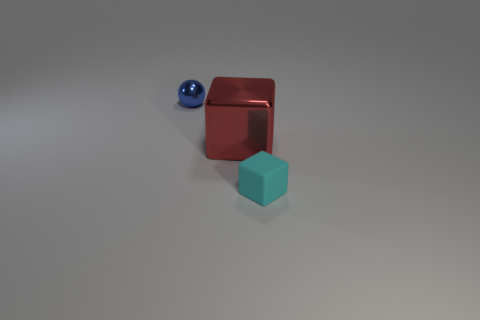What materials do the objects in the image seem to be made of? The objects in the image appear to be made of different materials: the blue sphere looks metallic with a reflective surface, the red cube seems to have a matte finish suggesting it could be plastic or painted wood, and the cyan cube also has a matte finish, indicative of a similar material as the red block. 